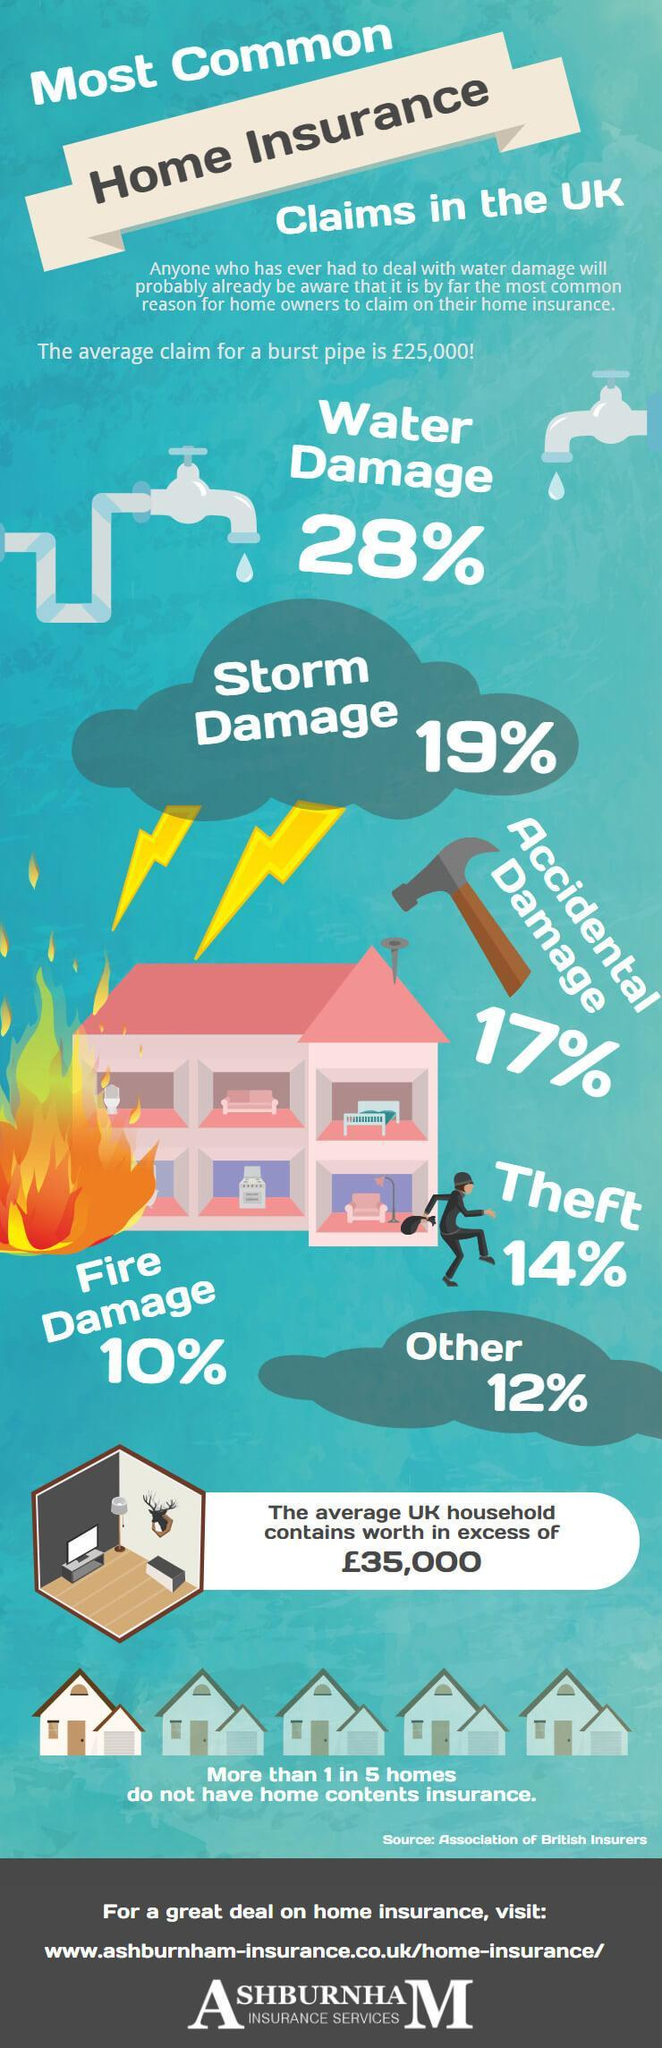How much can home owners claim for fire damage and theft?
Answer the question with a short phrase. 24% 